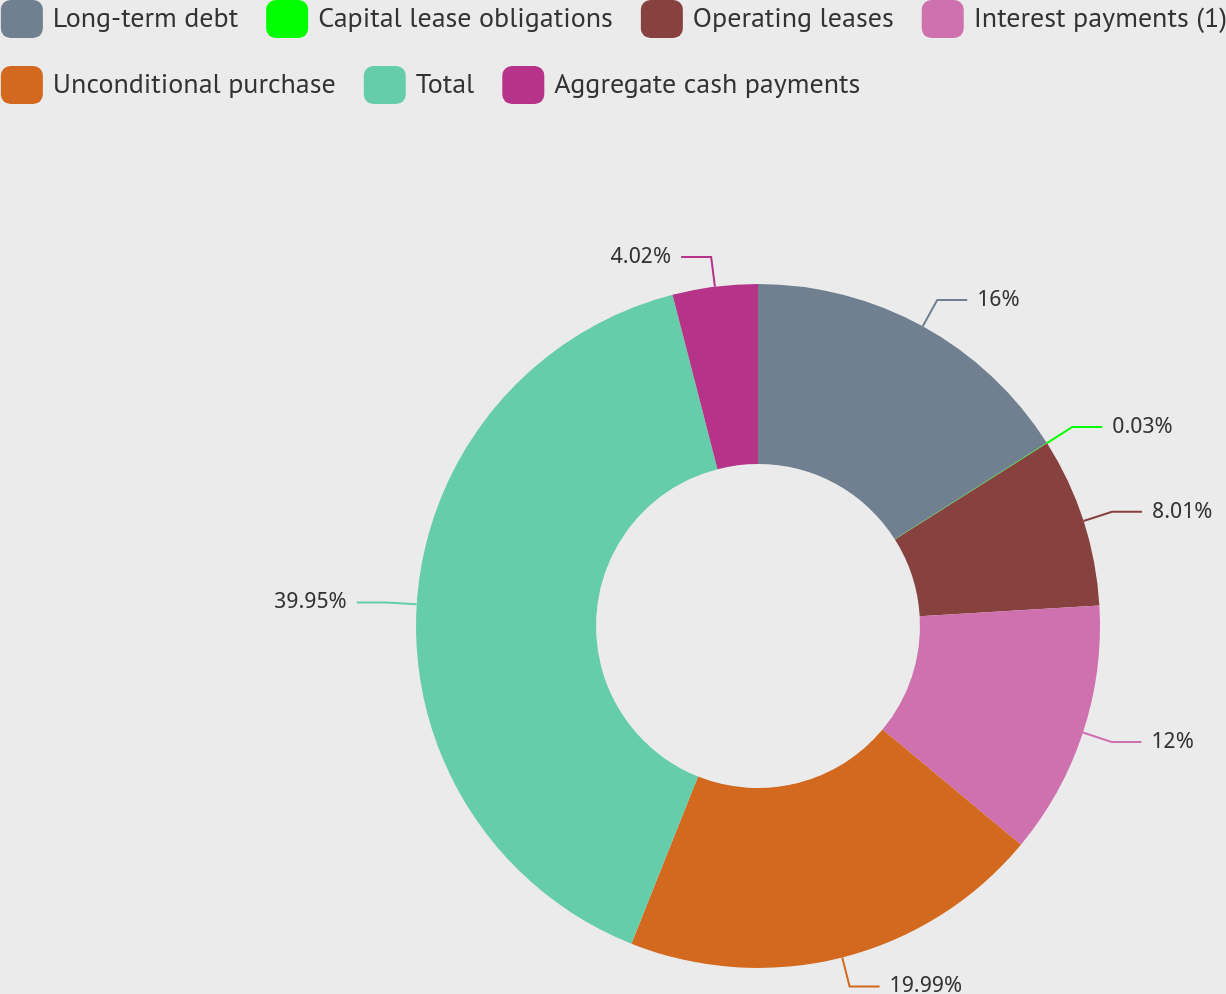<chart> <loc_0><loc_0><loc_500><loc_500><pie_chart><fcel>Long-term debt<fcel>Capital lease obligations<fcel>Operating leases<fcel>Interest payments (1)<fcel>Unconditional purchase<fcel>Total<fcel>Aggregate cash payments<nl><fcel>16.0%<fcel>0.03%<fcel>8.01%<fcel>12.0%<fcel>19.99%<fcel>39.94%<fcel>4.02%<nl></chart> 